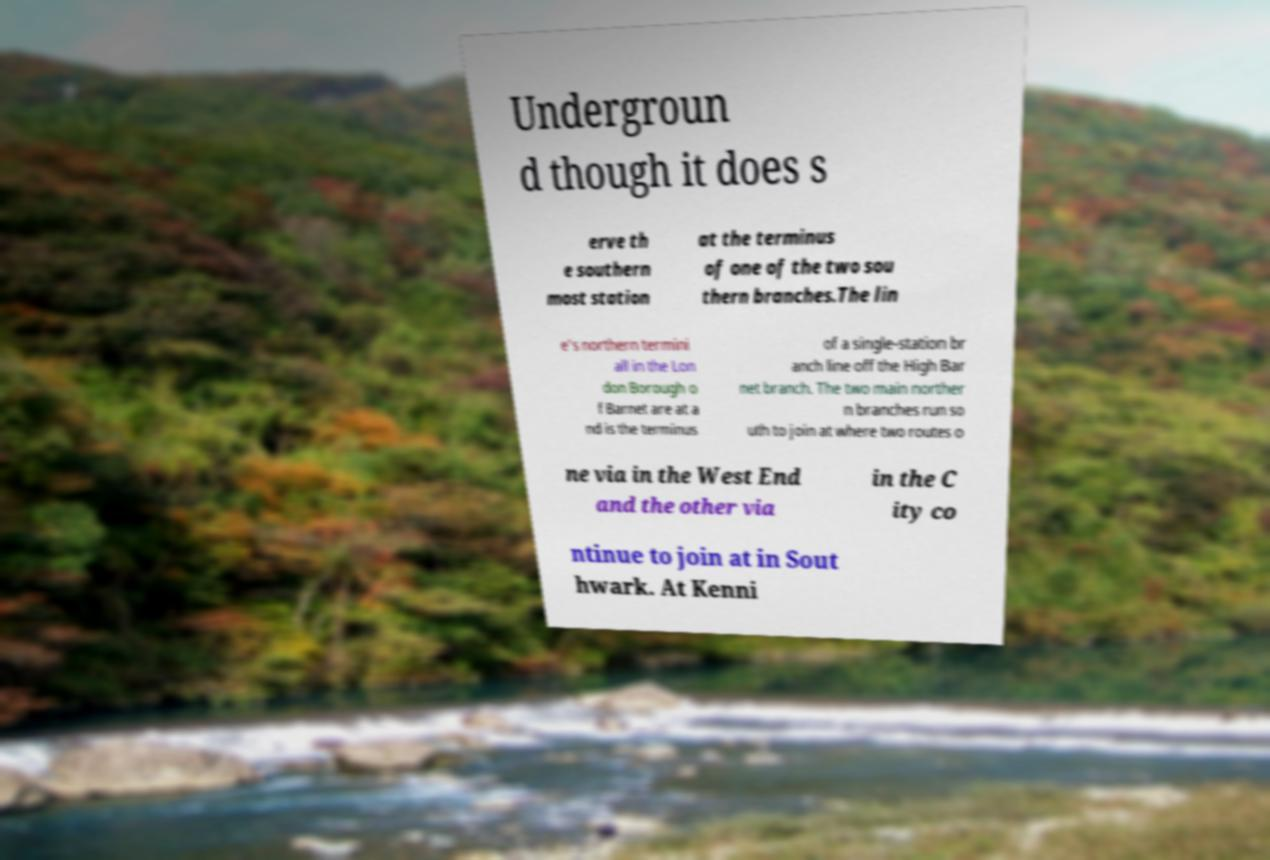For documentation purposes, I need the text within this image transcribed. Could you provide that? Undergroun d though it does s erve th e southern most station at the terminus of one of the two sou thern branches.The lin e's northern termini all in the Lon don Borough o f Barnet are at a nd is the terminus of a single-station br anch line off the High Bar net branch. The two main norther n branches run so uth to join at where two routes o ne via in the West End and the other via in the C ity co ntinue to join at in Sout hwark. At Kenni 